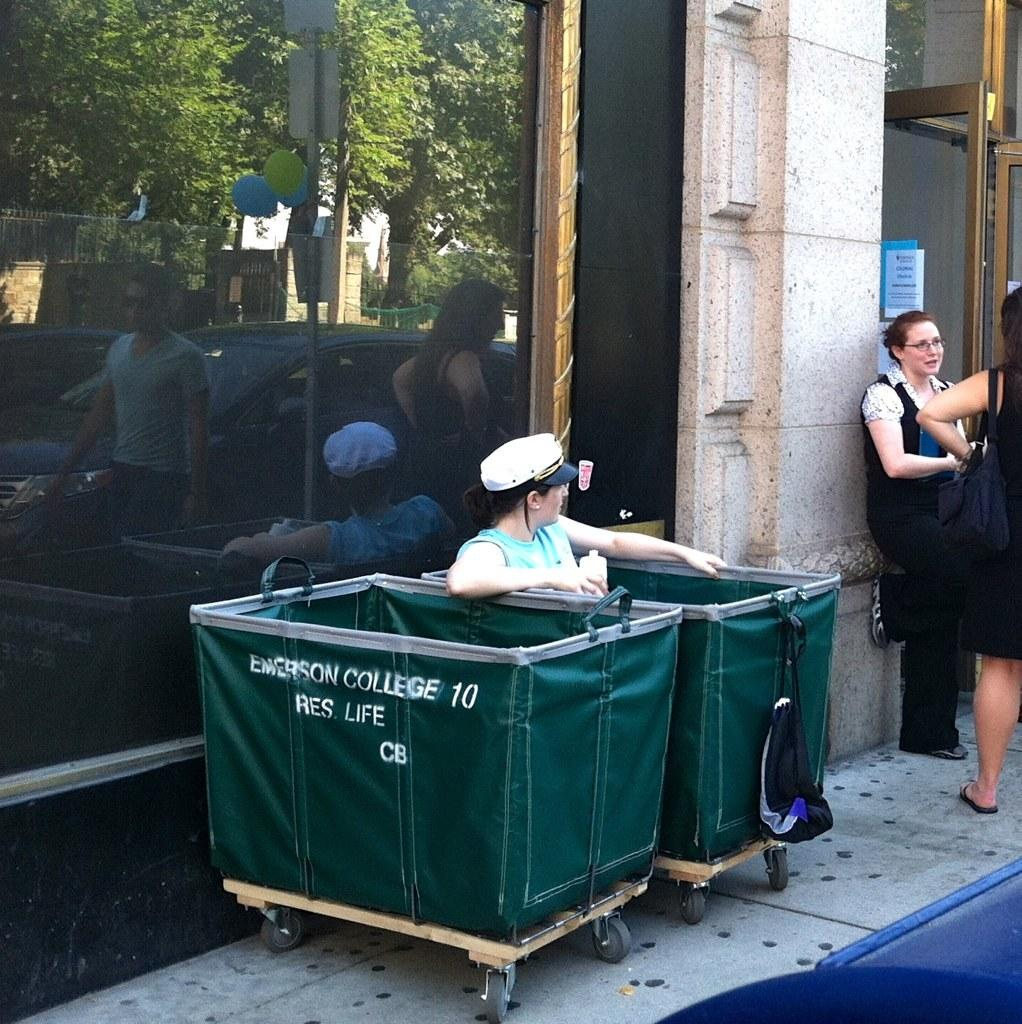<image>
Provide a brief description of the given image. Two bins with the logo for emerson college with a man sitting in one. 